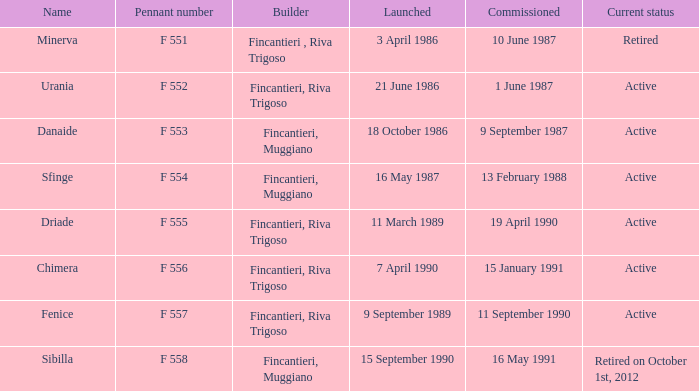Write the full table. {'header': ['Name', 'Pennant number', 'Builder', 'Launched', 'Commissioned', 'Current status'], 'rows': [['Minerva', 'F 551', 'Fincantieri , Riva Trigoso', '3 April 1986', '10 June 1987', 'Retired'], ['Urania', 'F 552', 'Fincantieri, Riva Trigoso', '21 June 1986', '1 June 1987', 'Active'], ['Danaide', 'F 553', 'Fincantieri, Muggiano', '18 October 1986', '9 September 1987', 'Active'], ['Sfinge', 'F 554', 'Fincantieri, Muggiano', '16 May 1987', '13 February 1988', 'Active'], ['Driade', 'F 555', 'Fincantieri, Riva Trigoso', '11 March 1989', '19 April 1990', 'Active'], ['Chimera', 'F 556', 'Fincantieri, Riva Trigoso', '7 April 1990', '15 January 1991', 'Active'], ['Fenice', 'F 557', 'Fincantieri, Riva Trigoso', '9 September 1989', '11 September 1990', 'Active'], ['Sibilla', 'F 558', 'Fincantieri, Muggiano', '15 September 1990', '16 May 1991', 'Retired on October 1st, 2012']]} What is the name of the builder who launched in danaide 18 October 1986. 